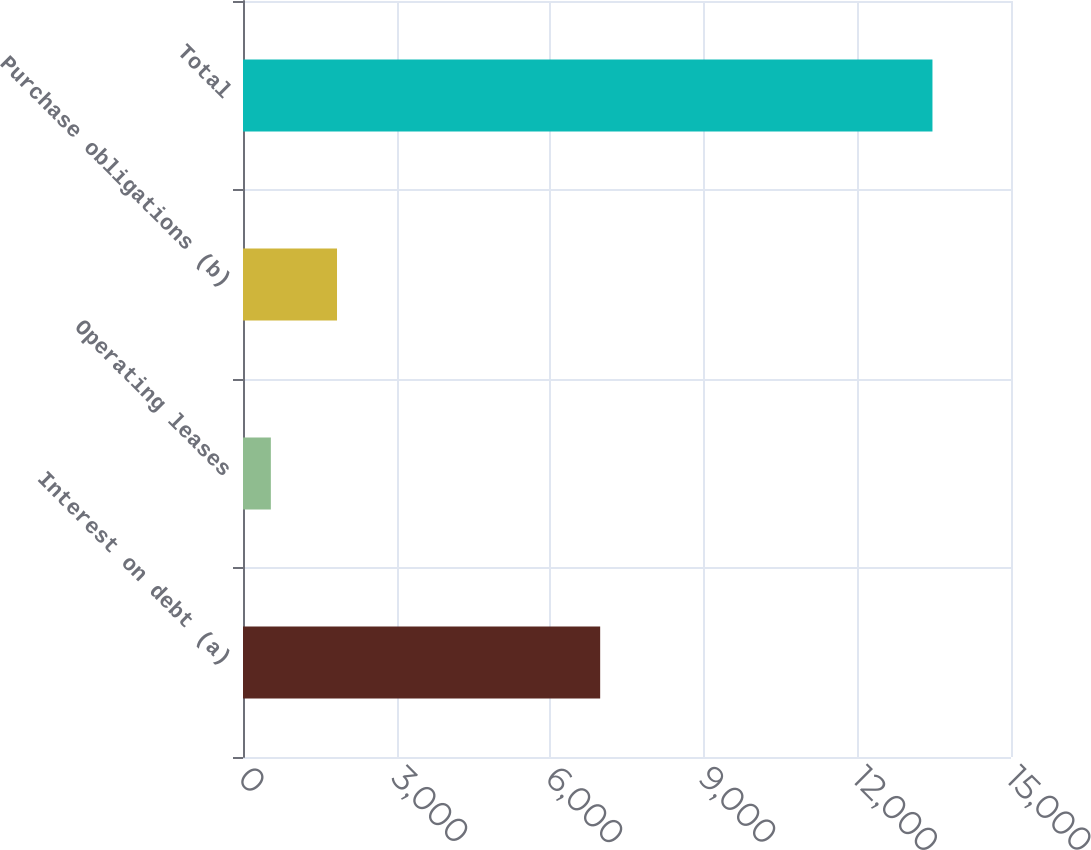Convert chart to OTSL. <chart><loc_0><loc_0><loc_500><loc_500><bar_chart><fcel>Interest on debt (a)<fcel>Operating leases<fcel>Purchase obligations (b)<fcel>Total<nl><fcel>6976<fcel>544<fcel>1836.2<fcel>13466<nl></chart> 